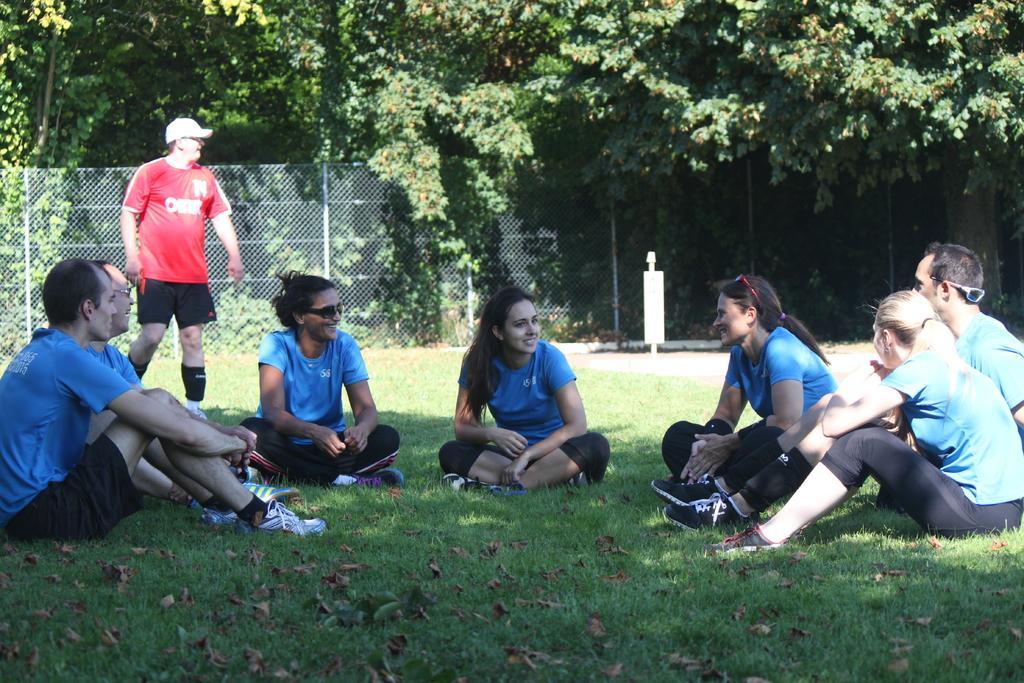Could you give a brief overview of what you see in this image? At the bottom of the image there is grass on the ground. On the ground there are few people sitting on the grass and all are wearing the blue t-shirts. Behind them at the left side there is a man with red t-shirt and a cap on his head is standing. Behind him there is a fencing. Behind the fencing there are trees. 